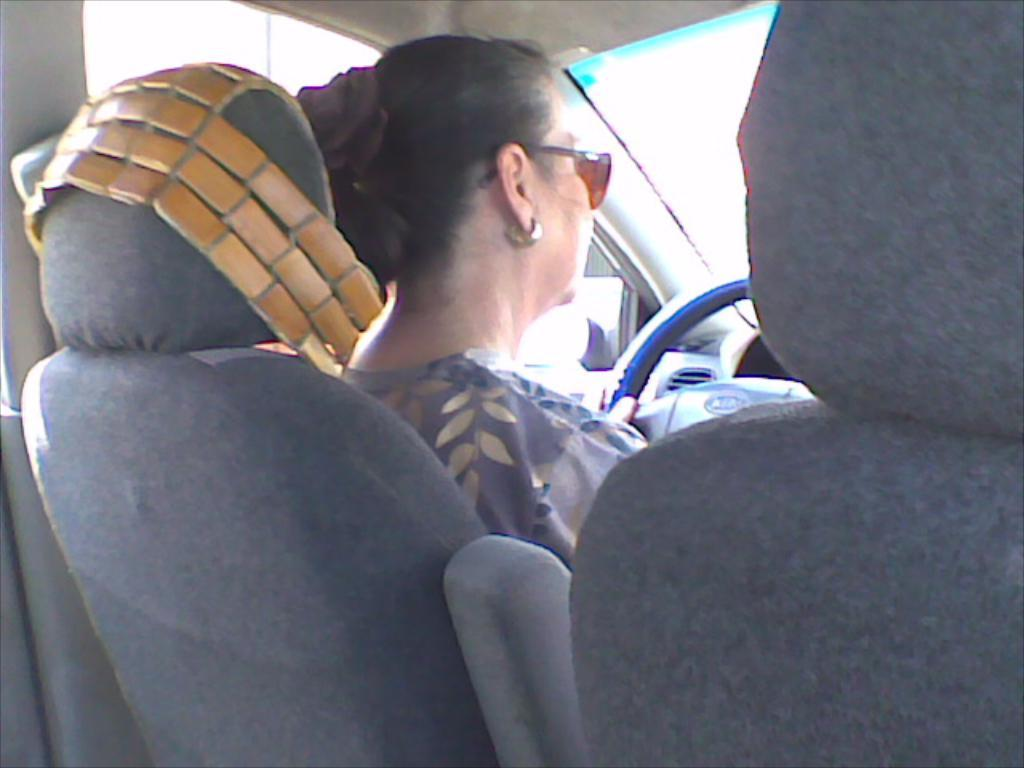What is the person in the image doing? The person is sitting inside a vehicle and holding the steering wheel. What is the person wearing in the image? The person is wearing a grey dress and glasses (specs). What type of knowledge is being shared at the bridge in the image? There is no bridge present in the image, and no knowledge is being shared. Where is the hospital located in the image? There is no hospital present in the image. 